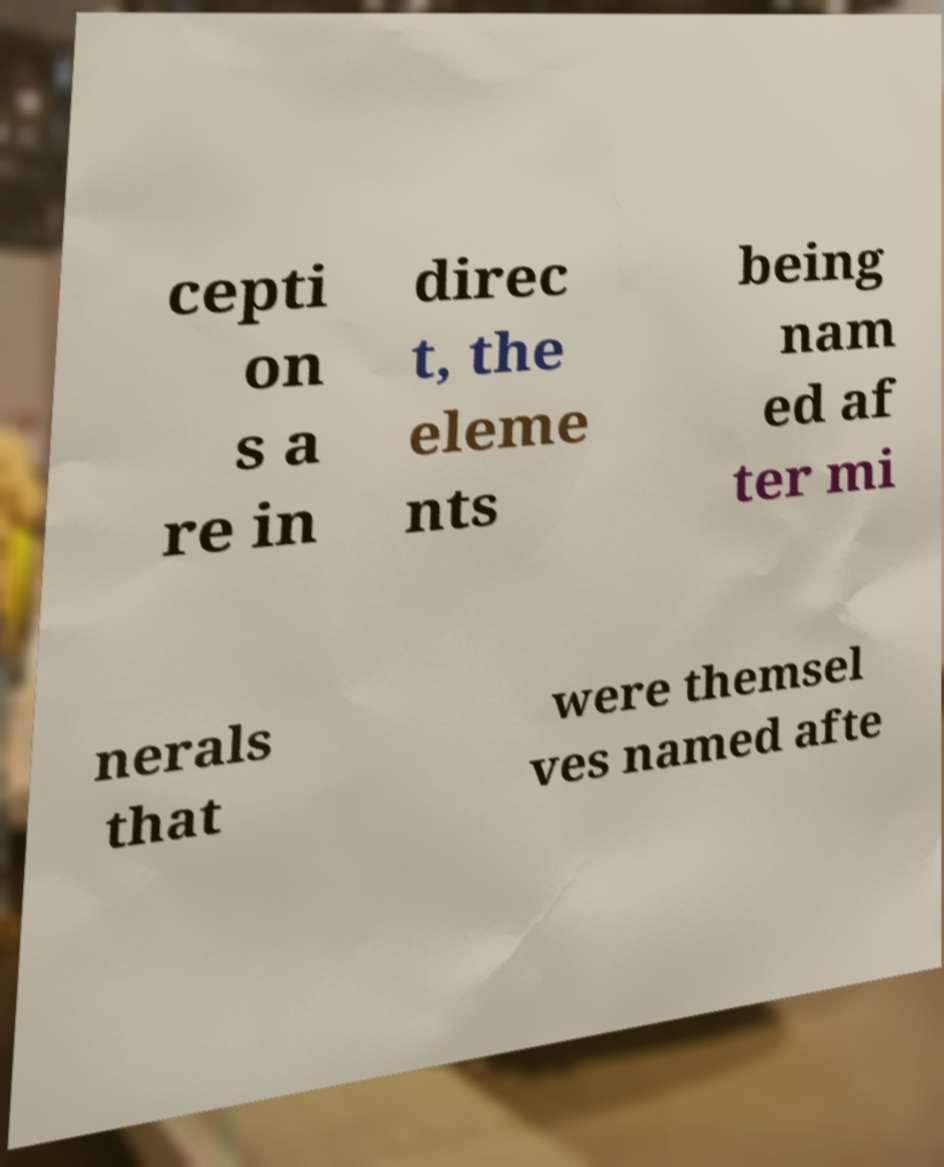Can you accurately transcribe the text from the provided image for me? cepti on s a re in direc t, the eleme nts being nam ed af ter mi nerals that were themsel ves named afte 